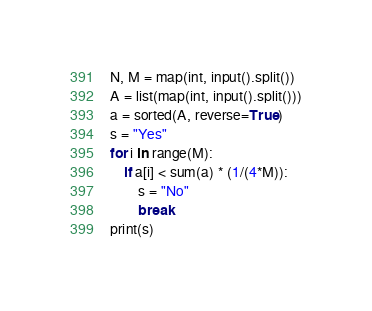<code> <loc_0><loc_0><loc_500><loc_500><_Python_>N, M = map(int, input().split())
A = list(map(int, input().split()))
a = sorted(A, reverse=True)
s = "Yes"
for i in range(M):
    if a[i] < sum(a) * (1/(4*M)):
        s = "No"
        break
print(s)</code> 